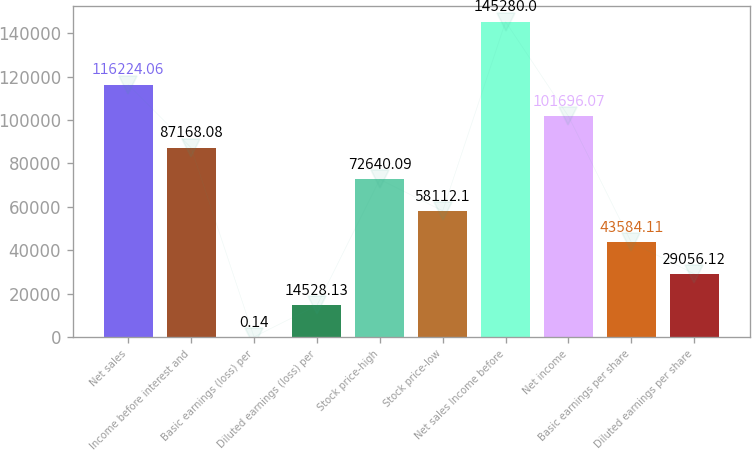Convert chart. <chart><loc_0><loc_0><loc_500><loc_500><bar_chart><fcel>Net sales<fcel>Income before interest and<fcel>Basic earnings (loss) per<fcel>Diluted earnings (loss) per<fcel>Stock price-high<fcel>Stock price-low<fcel>Net sales Income before<fcel>Net income<fcel>Basic earnings per share<fcel>Diluted earnings per share<nl><fcel>116224<fcel>87168.1<fcel>0.14<fcel>14528.1<fcel>72640.1<fcel>58112.1<fcel>145280<fcel>101696<fcel>43584.1<fcel>29056.1<nl></chart> 